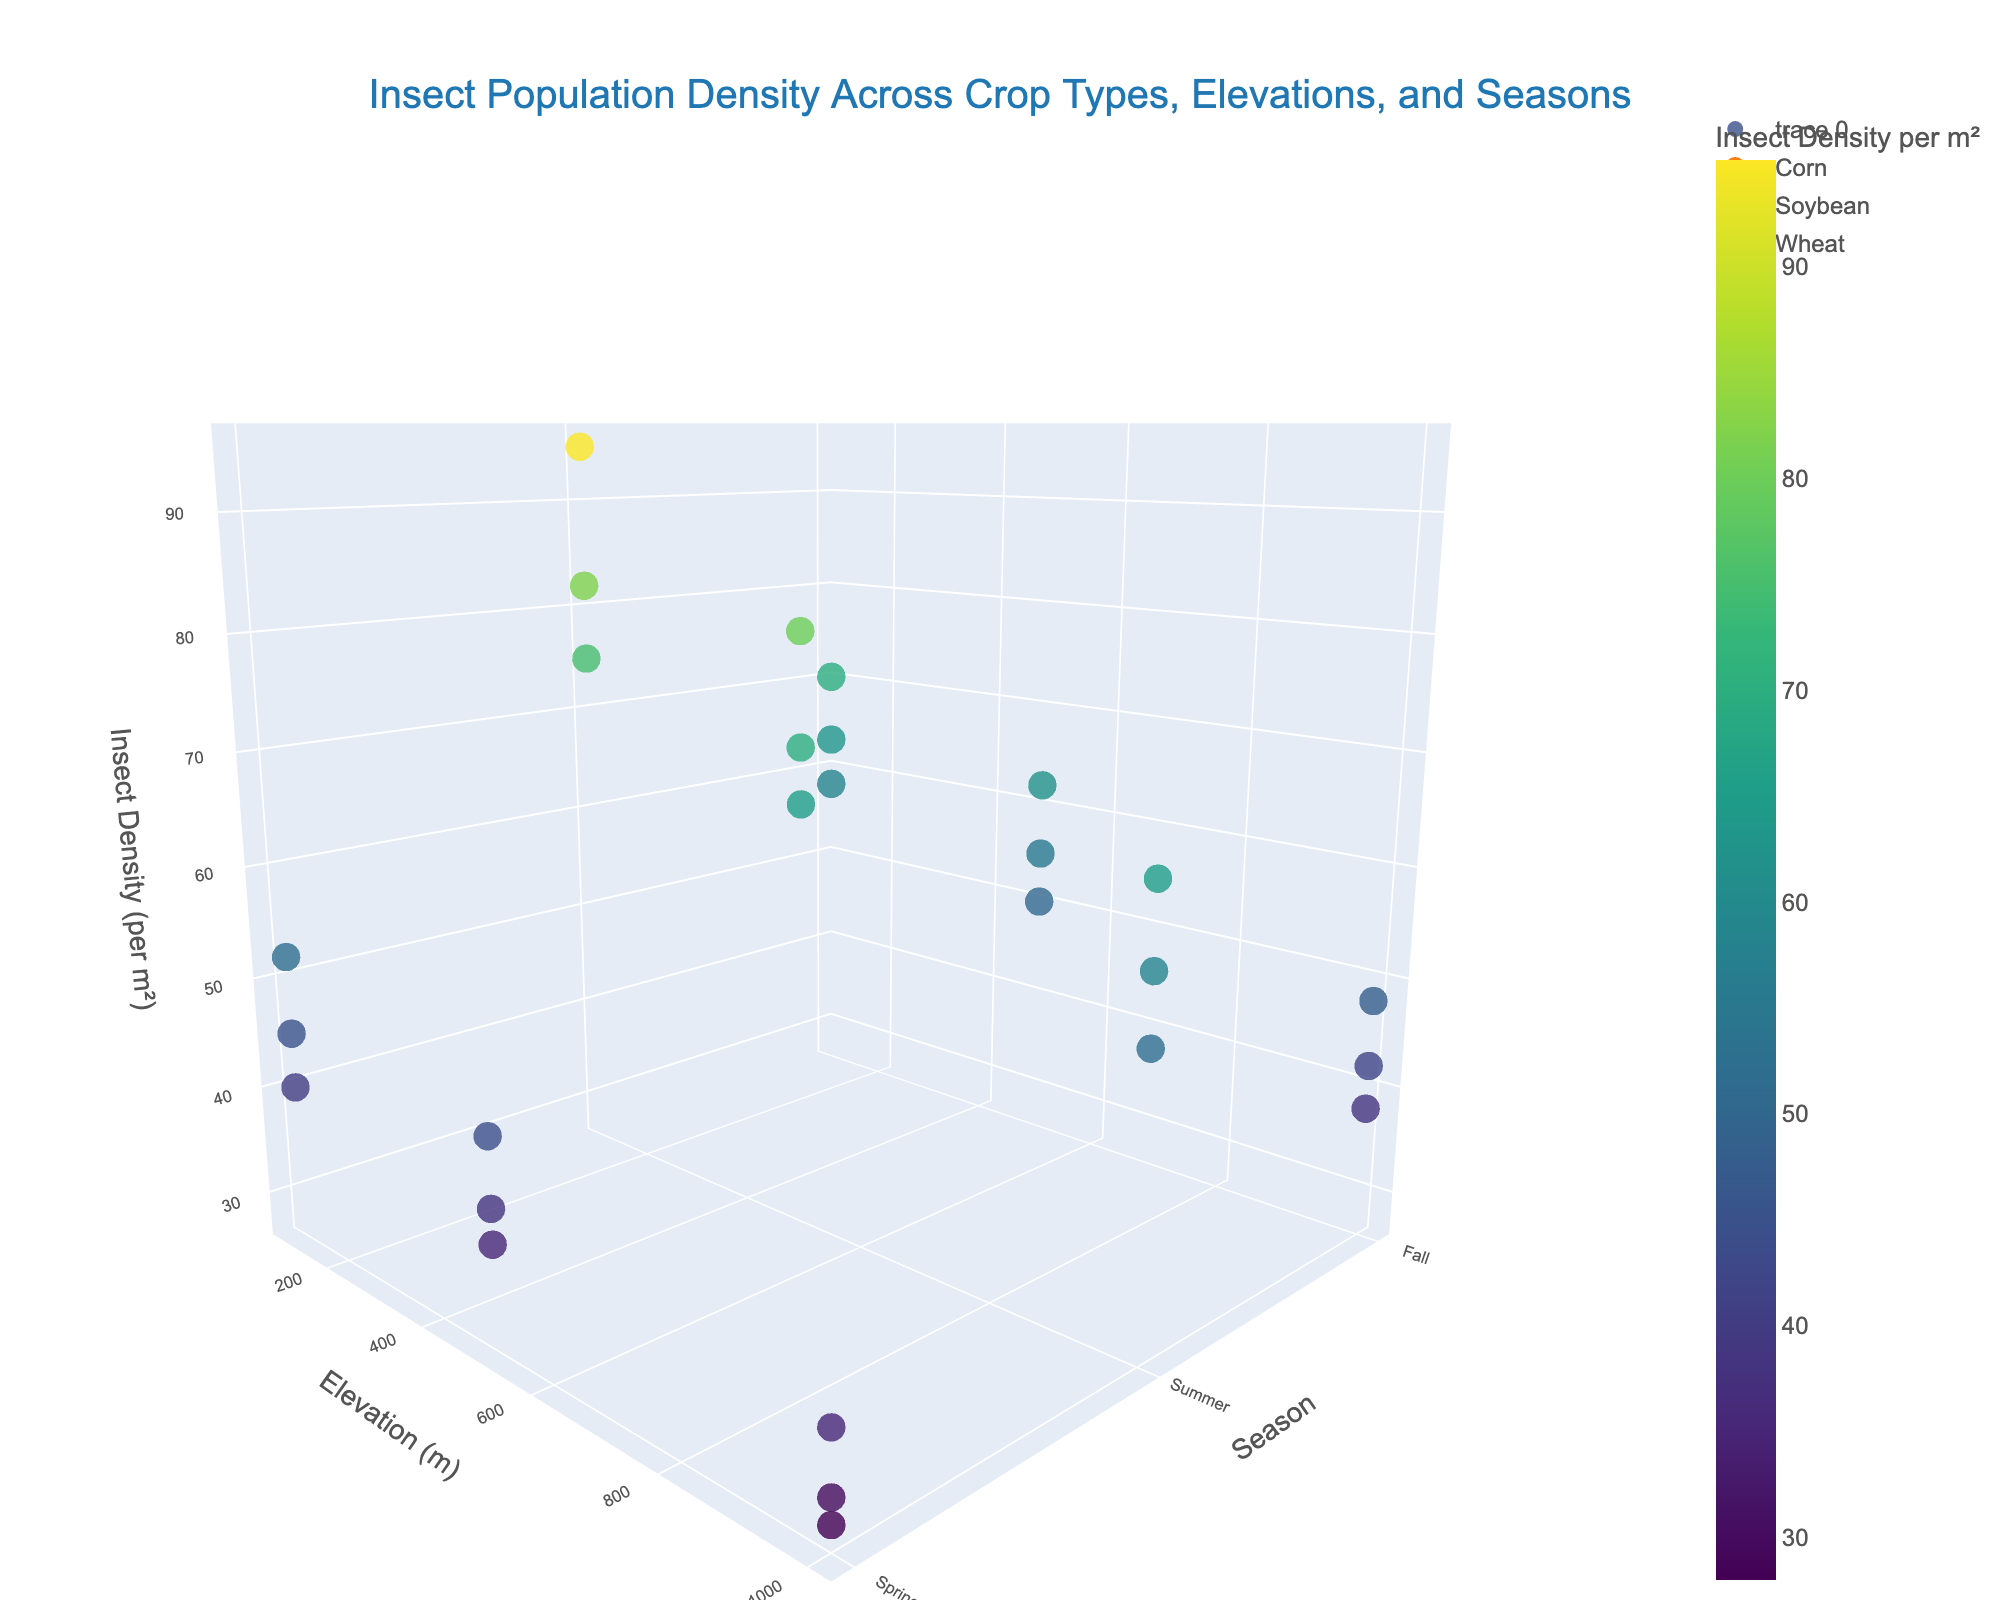What is the maximum insect density observed in the plot? To determine the maximum insect density, look for the highest value on the z-axis (Insect Density per m²). The color gradient and marker size can also help identify higher densities.
Answer: 95 Which season and elevation have the highest overall insect density for soybeans? From the data points, find the soybean crop and compare the insect densities across different elevations and seasons to locate the highest value, which occurs in Summer at 100m elevation.
Answer: Summer, 100m How does insect density change with elevation for corn during the summer? Examine the points corresponding to corn in summer across different elevations. Insect densities are: 82 (100m), 70 (500m), 58 (1000m). The density decreases as elevation increases.
Answer: Decreases with elevation What is the average insect density for wheat in the fall? Identify wheat points in fall and calculate the average of their insect densities: (58 + 50 + 38) / 3 = 146 / 3
Answer: 48.7 Which crop type shows the most variation in insect density across all seasons and elevations? By visually comparing the spread of insect densities for different crop types across all axes, soybeans have the largest range of insect densities from 35 to 95.
Answer: Soybean Is there a season that generally has higher insect densities across all crops and elevations? Compare the insect densities in spring, summer, and fall across all crops and elevations. Summer generally shows higher densities.
Answer: Summer Which crop type has the lowest insect density observed, and what are the conditions for that observation? Identify the lowest insect density value and check the associated crop type and conditions. The lowest density (28) is for wheat at 1000m elevation in spring.
Answer: Wheat, 1000m, Spring How do insect densities for soybean in spring compare to those for corn in the same season? Compare the spring insect densities for both crops: Soybean (52, 44, 35) and Corn (45, 38, 30). Soybean has higher densities than corn in spring.
Answer: Soybean densities are higher in spring What specific combination of crop type, elevation, and season results in an insect density of 55? Examine the data points to find the one with an insect density of 55. It's for Corn at 500m elevation in the fall.
Answer: Corn, 500m, Fall 